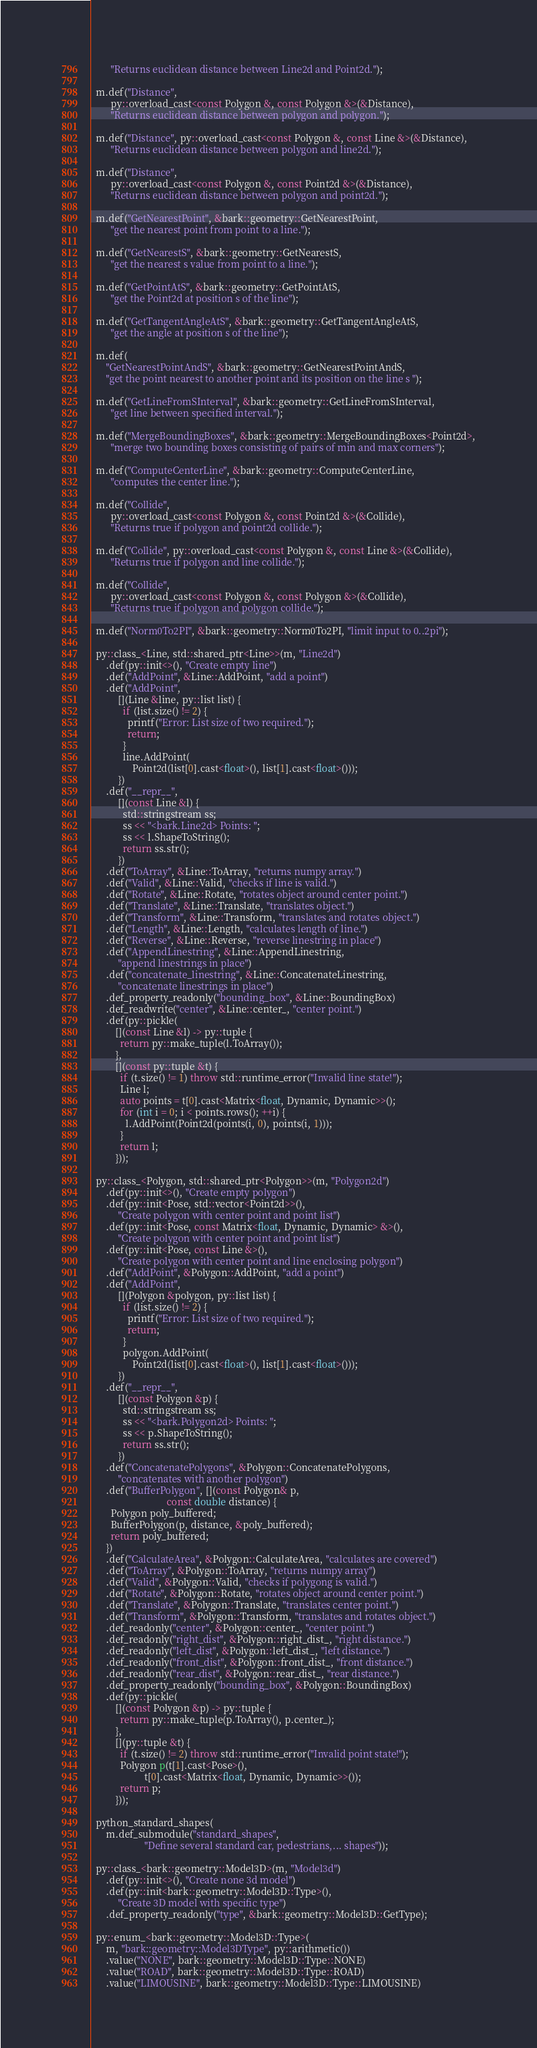<code> <loc_0><loc_0><loc_500><loc_500><_C++_>        "Returns euclidean distance between Line2d and Point2d.");

  m.def("Distance",
        py::overload_cast<const Polygon &, const Polygon &>(&Distance),
        "Returns euclidean distance between polygon and polygon.");

  m.def("Distance", py::overload_cast<const Polygon &, const Line &>(&Distance),
        "Returns euclidean distance between polygon and line2d.");

  m.def("Distance",
        py::overload_cast<const Polygon &, const Point2d &>(&Distance),
        "Returns euclidean distance between polygon and point2d.");

  m.def("GetNearestPoint", &bark::geometry::GetNearestPoint,
        "get the nearest point from point to a line.");

  m.def("GetNearestS", &bark::geometry::GetNearestS,
        "get the nearest s value from point to a line.");

  m.def("GetPointAtS", &bark::geometry::GetPointAtS,
        "get the Point2d at position s of the line");

  m.def("GetTangentAngleAtS", &bark::geometry::GetTangentAngleAtS,
        "get the angle at position s of the line");

  m.def(
      "GetNearestPointAndS", &bark::geometry::GetNearestPointAndS,
      "get the point nearest to another point and its position on the line s ");

  m.def("GetLineFromSInterval", &bark::geometry::GetLineFromSInterval,
        "get line between specified interval.");

  m.def("MergeBoundingBoxes", &bark::geometry::MergeBoundingBoxes<Point2d>,
        "merge two bounding boxes consisting of pairs of min and max corners");

  m.def("ComputeCenterLine", &bark::geometry::ComputeCenterLine,
        "computes the center line.");

  m.def("Collide",
        py::overload_cast<const Polygon &, const Point2d &>(&Collide),
        "Returns true if polygon and point2d collide.");

  m.def("Collide", py::overload_cast<const Polygon &, const Line &>(&Collide),
        "Returns true if polygon and line collide.");

  m.def("Collide",
        py::overload_cast<const Polygon &, const Polygon &>(&Collide),
        "Returns true if polygon and polygon collide.");

  m.def("Norm0To2PI", &bark::geometry::Norm0To2PI, "limit input to 0..2pi");

  py::class_<Line, std::shared_ptr<Line>>(m, "Line2d")
      .def(py::init<>(), "Create empty line")
      .def("AddPoint", &Line::AddPoint, "add a point")
      .def("AddPoint",
           [](Line &line, py::list list) {
             if (list.size() != 2) {
               printf("Error: List size of two required.");
               return;
             }
             line.AddPoint(
                 Point2d(list[0].cast<float>(), list[1].cast<float>()));
           })
      .def("__repr__",
           [](const Line &l) {
             std::stringstream ss;
             ss << "<bark.Line2d> Points: ";
             ss << l.ShapeToString();
             return ss.str();
           })
      .def("ToArray", &Line::ToArray, "returns numpy array.")
      .def("Valid", &Line::Valid, "checks if line is valid.")
      .def("Rotate", &Line::Rotate, "rotates object around center point.")
      .def("Translate", &Line::Translate, "translates object.")
      .def("Transform", &Line::Transform, "translates and rotates object.")
      .def("Length", &Line::Length, "calculates length of line.")
      .def("Reverse", &Line::Reverse, "reverse linestring in place")
      .def("AppendLinestring", &Line::AppendLinestring,
           "append linestrings in place")
      .def("concatenate_linestring", &Line::ConcatenateLinestring,
           "concatenate linestrings in place")
      .def_property_readonly("bounding_box", &Line::BoundingBox)
      .def_readwrite("center", &Line::center_, "center point.")
      .def(py::pickle(
          [](const Line &l) -> py::tuple {
            return py::make_tuple(l.ToArray());
          },
          [](const py::tuple &t) {
            if (t.size() != 1) throw std::runtime_error("Invalid line state!");
            Line l;
            auto points = t[0].cast<Matrix<float, Dynamic, Dynamic>>();
            for (int i = 0; i < points.rows(); ++i) {
              l.AddPoint(Point2d(points(i, 0), points(i, 1)));
            }
            return l;
          }));

  py::class_<Polygon, std::shared_ptr<Polygon>>(m, "Polygon2d")
      .def(py::init<>(), "Create empty polygon")
      .def(py::init<Pose, std::vector<Point2d>>(),
           "Create polygon with center point and point list")
      .def(py::init<Pose, const Matrix<float, Dynamic, Dynamic> &>(),
           "Create polygon with center point and point list")
      .def(py::init<Pose, const Line &>(),
           "Create polygon with center point and line enclosing polygon")
      .def("AddPoint", &Polygon::AddPoint, "add a point")
      .def("AddPoint",
           [](Polygon &polygon, py::list list) {
             if (list.size() != 2) {
               printf("Error: List size of two required.");
               return;
             }
             polygon.AddPoint(
                 Point2d(list[0].cast<float>(), list[1].cast<float>()));
           })
      .def("__repr__",
           [](const Polygon &p) {
             std::stringstream ss;
             ss << "<bark.Polygon2d> Points: ";
             ss << p.ShapeToString();
             return ss.str();
           })
      .def("ConcatenatePolygons", &Polygon::ConcatenatePolygons,
           "concatenates with another polygon")
      .def("BufferPolygon", [](const Polygon& p,
                               const double distance) {
        Polygon poly_buffered;
        BufferPolygon(p, distance, &poly_buffered);
        return poly_buffered;
      })
      .def("CalculateArea", &Polygon::CalculateArea, "calculates are covered")
      .def("ToArray", &Polygon::ToArray, "returns numpy array")
      .def("Valid", &Polygon::Valid, "checks if polygong is valid.")
      .def("Rotate", &Polygon::Rotate, "rotates object around center point.")
      .def("Translate", &Polygon::Translate, "translates center point.")
      .def("Transform", &Polygon::Transform, "translates and rotates object.")
      .def_readonly("center", &Polygon::center_, "center point.")
      .def_readonly("right_dist", &Polygon::right_dist_, "right distance.")
      .def_readonly("left_dist", &Polygon::left_dist_, "left distance.")
      .def_readonly("front_dist", &Polygon::front_dist_, "front distance.")
      .def_readonly("rear_dist", &Polygon::rear_dist_, "rear distance.")
      .def_property_readonly("bounding_box", &Polygon::BoundingBox)
      .def(py::pickle(
          [](const Polygon &p) -> py::tuple {
            return py::make_tuple(p.ToArray(), p.center_);
          },
          [](py::tuple &t) {
            if (t.size() != 2) throw std::runtime_error("Invalid point state!");
            Polygon p(t[1].cast<Pose>(),
                      t[0].cast<Matrix<float, Dynamic, Dynamic>>());
            return p;
          }));

  python_standard_shapes(
      m.def_submodule("standard_shapes",
                      "Define several standard car, pedestrians,... shapes"));

  py::class_<bark::geometry::Model3D>(m, "Model3d")
      .def(py::init<>(), "Create none 3d model")
      .def(py::init<bark::geometry::Model3D::Type>(),
           "Create 3D model with specific type")
      .def_property_readonly("type", &bark::geometry::Model3D::GetType);

  py::enum_<bark::geometry::Model3D::Type>(
      m, "bark::geometry::Model3DType", py::arithmetic())
      .value("NONE", bark::geometry::Model3D::Type::NONE)
      .value("ROAD", bark::geometry::Model3D::Type::ROAD)
      .value("LIMOUSINE", bark::geometry::Model3D::Type::LIMOUSINE)</code> 